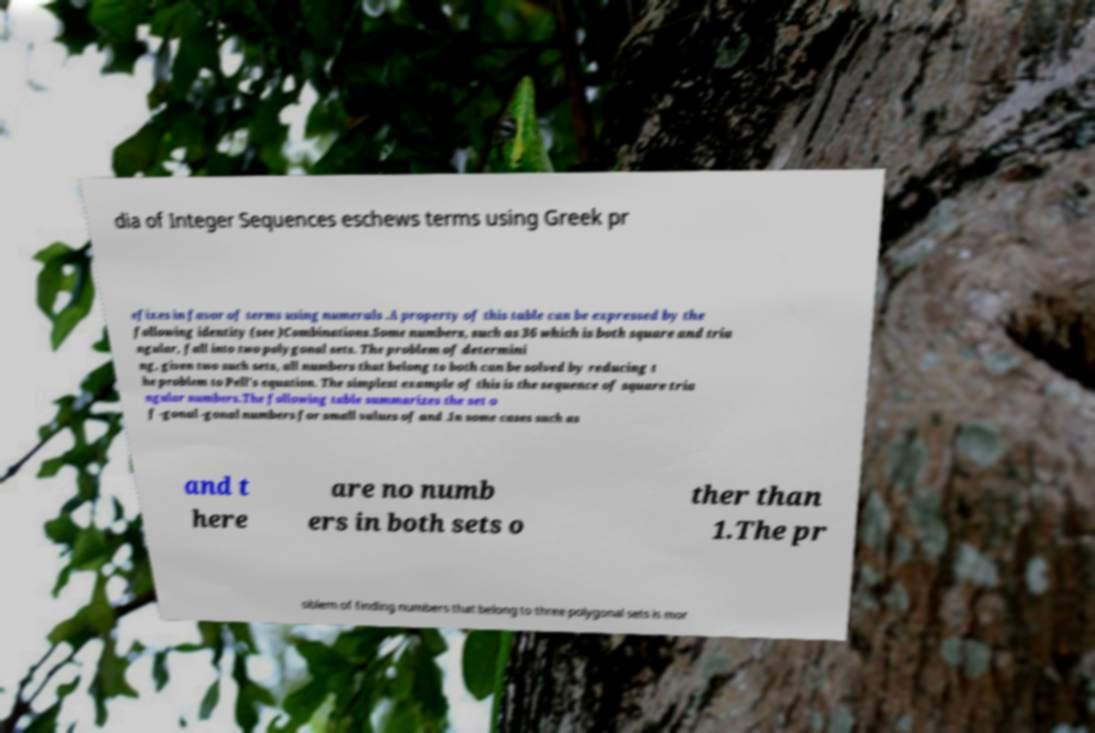Could you assist in decoding the text presented in this image and type it out clearly? dia of Integer Sequences eschews terms using Greek pr efixes in favor of terms using numerals .A property of this table can be expressed by the following identity (see )Combinations.Some numbers, such as 36 which is both square and tria ngular, fall into two polygonal sets. The problem of determini ng, given two such sets, all numbers that belong to both can be solved by reducing t he problem to Pell's equation. The simplest example of this is the sequence of square tria ngular numbers.The following table summarizes the set o f -gonal -gonal numbers for small values of and .In some cases such as and t here are no numb ers in both sets o ther than 1.The pr oblem of finding numbers that belong to three polygonal sets is mor 